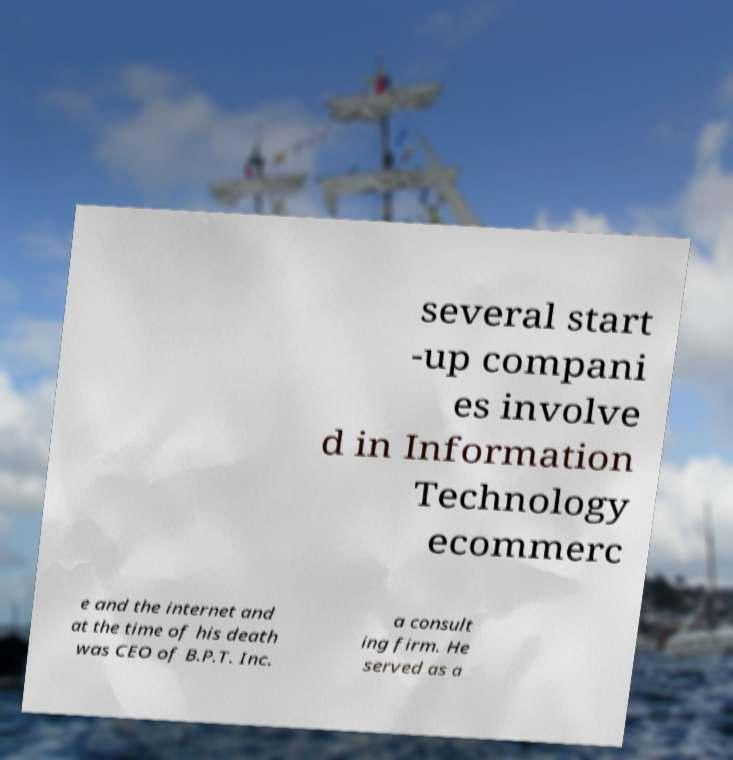Could you assist in decoding the text presented in this image and type it out clearly? several start -up compani es involve d in Information Technology ecommerc e and the internet and at the time of his death was CEO of B.P.T. Inc. a consult ing firm. He served as a 